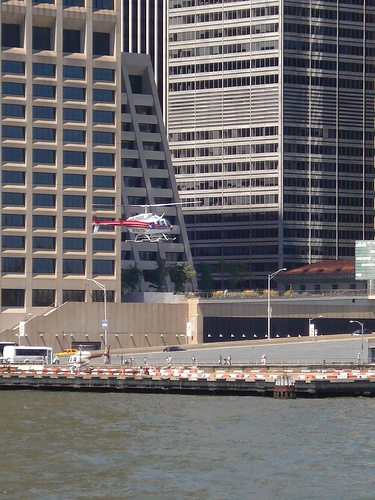<image>
Is the tower in front of the heli? No. The tower is not in front of the heli. The spatial positioning shows a different relationship between these objects. 